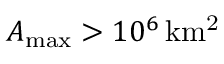<formula> <loc_0><loc_0><loc_500><loc_500>{ A _ { \max } } > 1 0 ^ { 6 } \, { k m ^ { 2 } }</formula> 